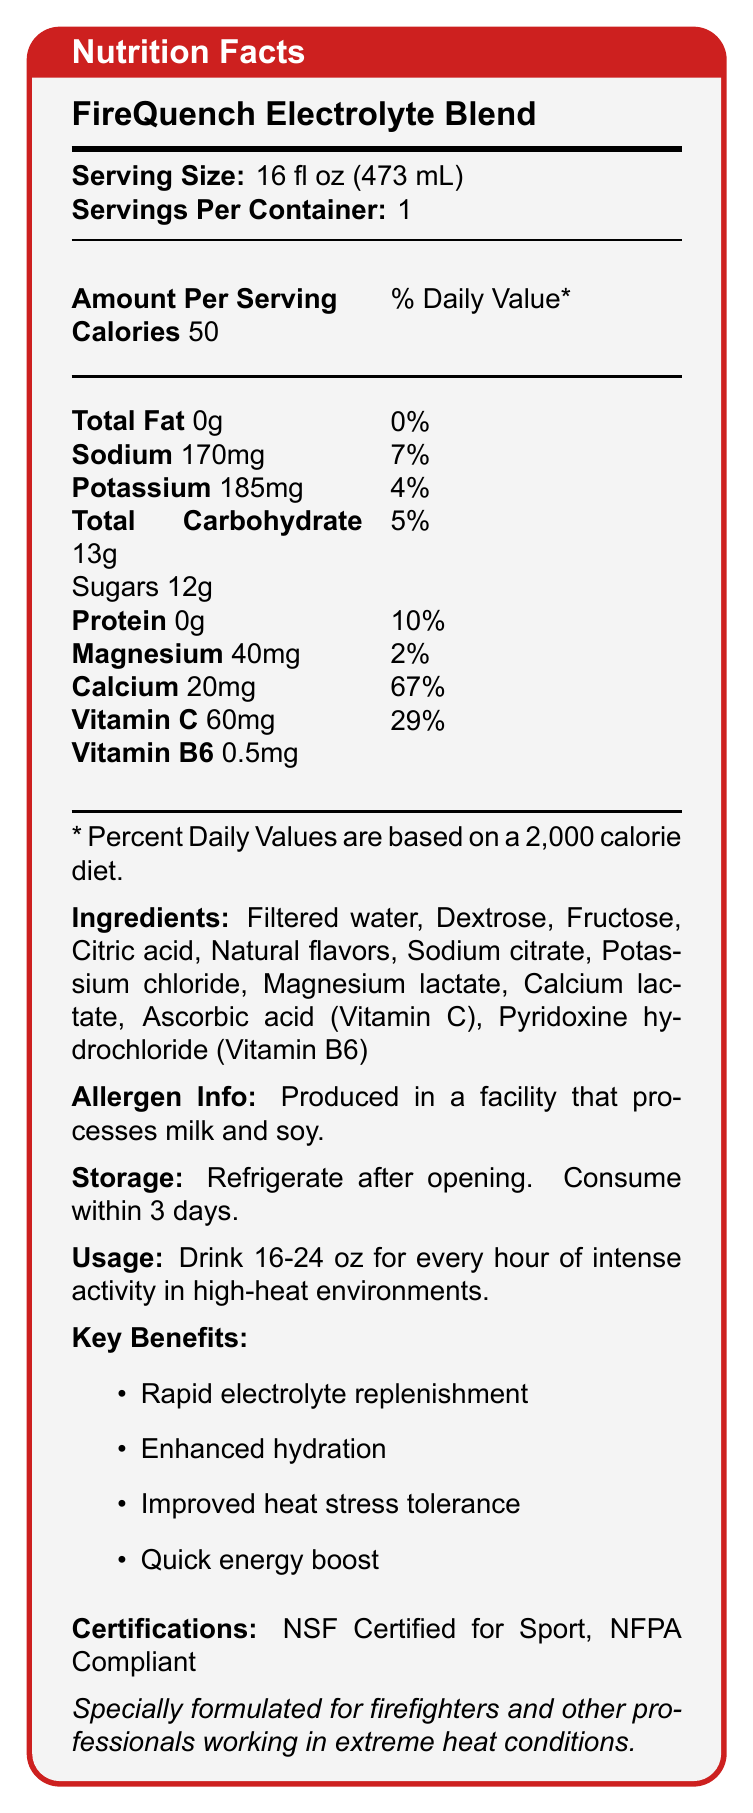What is the serving size of the FireQuench Electrolyte Blend? The document states that the serving size is 16 fl oz (473 mL).
Answer: 16 fl oz (473 mL) How many calories are in one serving of the FireQuench Electrolyte Blend? The document lists the amount of calories per serving as 50.
Answer: 50 What is the amount of sodium in one serving? The document states that one serving of FireQuench Electrolyte Blend contains 170mg of sodium.
Answer: 170mg What percentage of the daily value is vitamin C in this drink? According to the document, the drink provides 67% of the daily value for vitamin C.
Answer: 67% What are the main ingredients of the FireQuench Electrolyte Blend? The document lists the main ingredients in the drink.
Answer: Filtered water, dextrose, fructose, citric acid, natural flavors, sodium citrate, potassium chloride, magnesium lactate, calcium lactate, ascorbic acid (Vitamin C), pyridoxine hydrochloride (Vitamin B6) Which of the following benefits is NOT listed for FireQuench Electrolyte Blend? A. Improved vision B. Rapid electrolyte replenishment C. Enhanced hydration D. Improved heat stress tolerance The listed benefits are rapid electrolyte replenishment, enhanced hydration, improved heat stress tolerance, and a quick energy boost. Improved vision is not mentioned.
Answer: A. Improved vision How many grams of sugar are in one serving of the FireQuench Electrolyte Blend? A. 0g B. 5g C. 12g D. 20g The document specifies that one serving contains 12g of sugar.
Answer: C. 12g Is the FireQuench Electrolyte Blend NSF Certified for Sport? The document mentions that the drink is NSF Certified for Sport.
Answer: Yes Summarize the main purpose and key components of the FireQuench Electrolyte Blend. This summary captures the primary purpose, key ingredients, and main benefits of the FireQuench Electrolyte Blend as described in the document.
Answer: The FireQuench Electrolyte Blend is a specially formulated electrolyte drink designed to combat dehydration and improve heat stress tolerance for firefighters and other professionals working in extreme heat conditions. It contains essential electrolytes like sodium, potassium, magnesium, and calcium, along with vitamins C and B6. The drink provides rapid electrolyte replenishment, enhanced hydration, and quick energy, and it is NSF Certified for Sport and NFPA Compliant. How much potassium is in one serving and what percentage of the daily value does it provide? The drink contains 185mg of potassium per serving, providing 4% of the daily value for potassium.
Answer: 185mg, 4% What should you do with the drink after opening it? The storage instructions state that you should refrigerate the drink after opening and consume it within 3 days.
Answer: Refrigerate and consume within 3 days In what type of facility is the FireQuench Electrolyte Blend produced? The document notes that the drink is produced in a facility that processes milk and soy.
Answer: A facility that processes milk and soy Which vitamin is included in a higher percentage of the daily value, Vitamin C or Vitamin B6? The drink provides 67% of the daily value for Vitamin C and 29% for Vitamin B6, making Vitamin C the higher percentage.
Answer: Vitamin C What is the main use recommendation for the FireQuench Electrolyte Blend during intense activities? The usage instructions suggest drinking 16-24 oz for every hour of intense activity in high-heat conditions.
Answer: Drink 16-24 oz for every hour of intense activity in high-heat environments How many grams of protein are in the FireQuench Electrolyte Blend? The document states that there are 0 grams of protein in the drink.
Answer: 0g What is the main idea of the document? This point summarizes the core content, highlighting the purpose, detailed information, and benefits targeted at the intended users.
Answer: The document provides nutritional and usage information for the FireQuench Electrolyte Blend, a specially formulated drink for professionals working in extreme heat conditions, detailing its ingredients, benefits, and certifications. Who is the primary target audience for the FireQuench Electrolyte Blend? The document explicitly states that the drink is specially formulated for firefighters and other professionals in high-heat environments.
Answer: Firefighters and other professionals working in extreme heat conditions Does the FireQuench Electrolyte Blend contain any artificial flavors? The document only mentions "natural flavors" but does not provide information on the presence or absence of artificial flavors.
Answer: Cannot be determined 